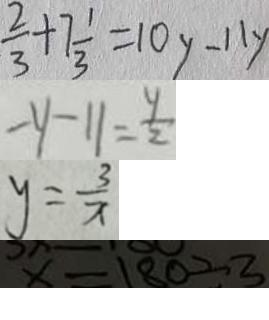<formula> <loc_0><loc_0><loc_500><loc_500>\frac { 2 } { 3 } + 7 \frac { 1 } { 3 } = 1 0 y - 1 1 y 
 - y - 1 1 = \frac { y } { 2 } 
 y = \frac { 3 } { x } 
 x = 1 8 0 \div 3</formula> 